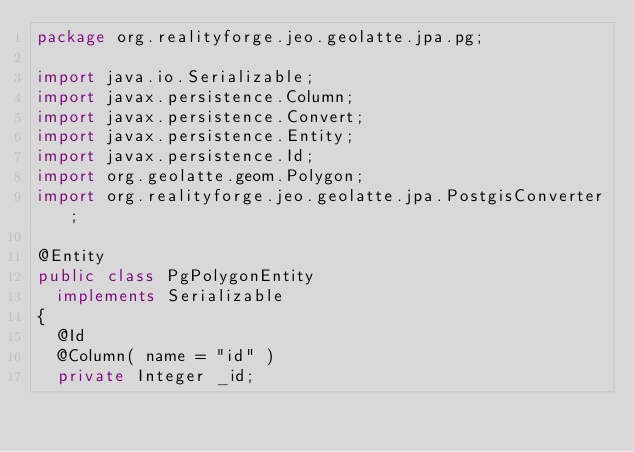Convert code to text. <code><loc_0><loc_0><loc_500><loc_500><_Java_>package org.realityforge.jeo.geolatte.jpa.pg;

import java.io.Serializable;
import javax.persistence.Column;
import javax.persistence.Convert;
import javax.persistence.Entity;
import javax.persistence.Id;
import org.geolatte.geom.Polygon;
import org.realityforge.jeo.geolatte.jpa.PostgisConverter;

@Entity
public class PgPolygonEntity
  implements Serializable
{
  @Id
  @Column( name = "id" )
  private Integer _id;
</code> 